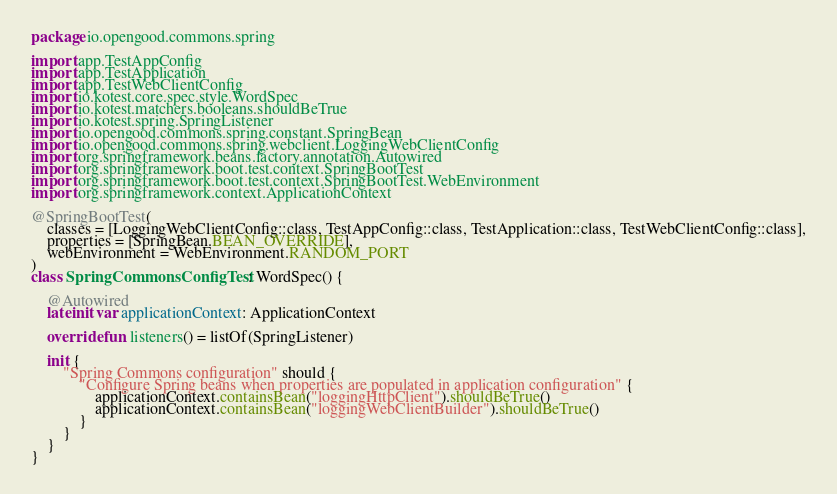<code> <loc_0><loc_0><loc_500><loc_500><_Kotlin_>package io.opengood.commons.spring

import app.TestAppConfig
import app.TestApplication
import app.TestWebClientConfig
import io.kotest.core.spec.style.WordSpec
import io.kotest.matchers.booleans.shouldBeTrue
import io.kotest.spring.SpringListener
import io.opengood.commons.spring.constant.SpringBean
import io.opengood.commons.spring.webclient.LoggingWebClientConfig
import org.springframework.beans.factory.annotation.Autowired
import org.springframework.boot.test.context.SpringBootTest
import org.springframework.boot.test.context.SpringBootTest.WebEnvironment
import org.springframework.context.ApplicationContext

@SpringBootTest(
    classes = [LoggingWebClientConfig::class, TestAppConfig::class, TestApplication::class, TestWebClientConfig::class],
    properties = [SpringBean.BEAN_OVERRIDE],
    webEnvironment = WebEnvironment.RANDOM_PORT
)
class SpringCommonsConfigTest : WordSpec() {

    @Autowired
    lateinit var applicationContext: ApplicationContext

    override fun listeners() = listOf(SpringListener)

    init {
        "Spring Commons configuration" should {
            "Configure Spring beans when properties are populated in application configuration" {
                applicationContext.containsBean("loggingHttpClient").shouldBeTrue()
                applicationContext.containsBean("loggingWebClientBuilder").shouldBeTrue()
            }
        }
    }
}
</code> 